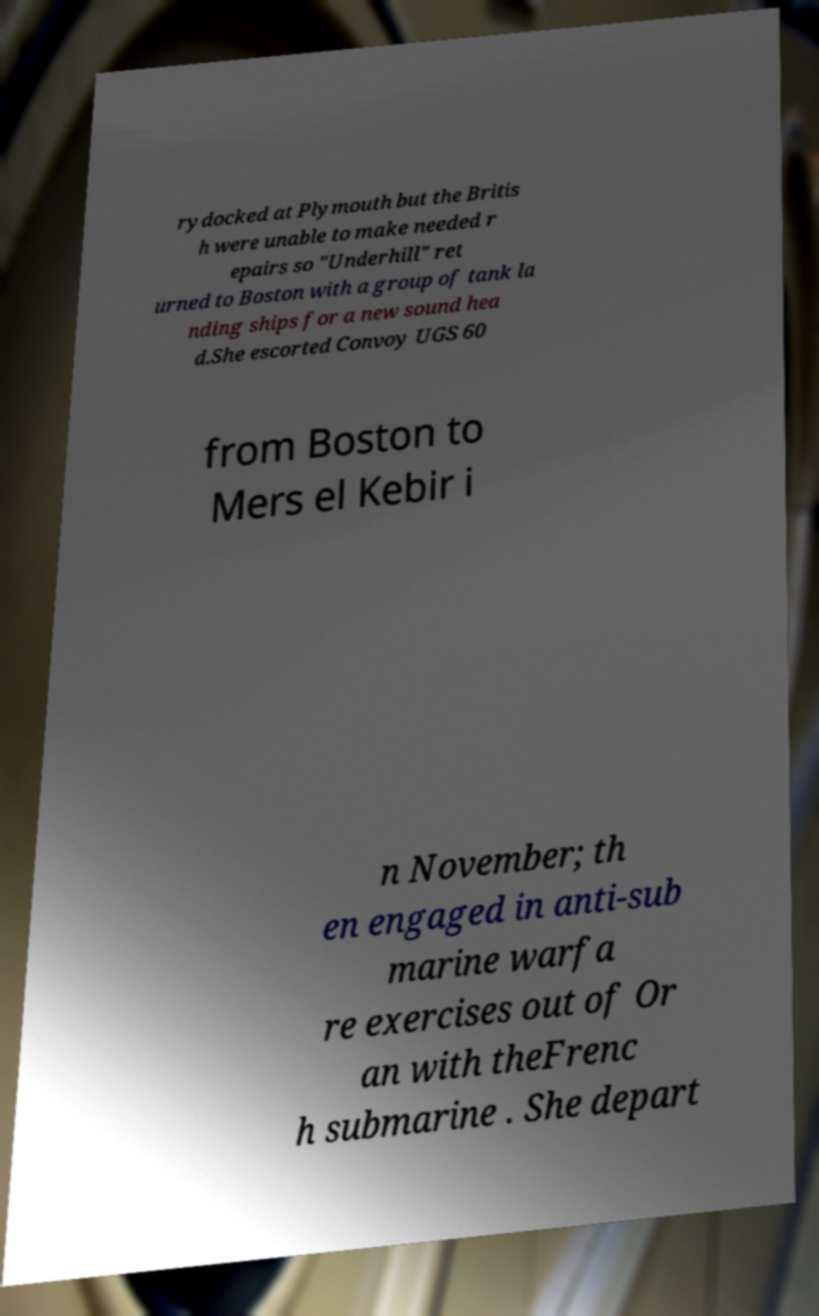Can you accurately transcribe the text from the provided image for me? rydocked at Plymouth but the Britis h were unable to make needed r epairs so "Underhill" ret urned to Boston with a group of tank la nding ships for a new sound hea d.She escorted Convoy UGS 60 from Boston to Mers el Kebir i n November; th en engaged in anti-sub marine warfa re exercises out of Or an with theFrenc h submarine . She depart 